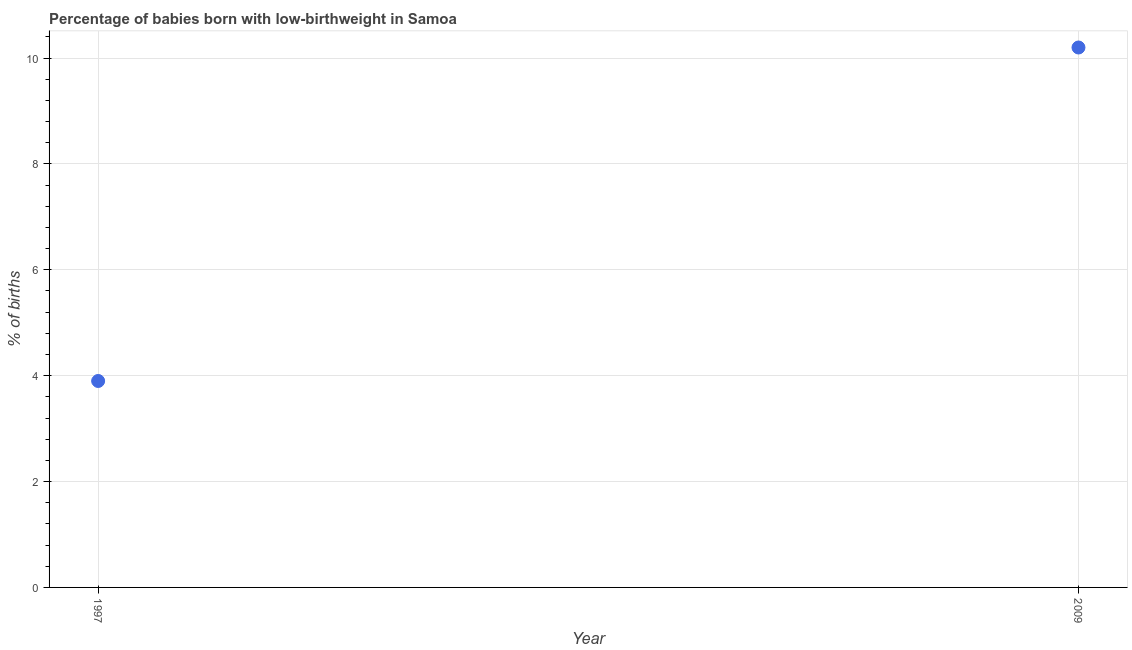What is the percentage of babies who were born with low-birthweight in 1997?
Your answer should be very brief. 3.9. In which year was the percentage of babies who were born with low-birthweight maximum?
Ensure brevity in your answer.  2009. What is the difference between the percentage of babies who were born with low-birthweight in 1997 and 2009?
Keep it short and to the point. -6.3. What is the average percentage of babies who were born with low-birthweight per year?
Ensure brevity in your answer.  7.05. What is the median percentage of babies who were born with low-birthweight?
Give a very brief answer. 7.05. Do a majority of the years between 2009 and 1997 (inclusive) have percentage of babies who were born with low-birthweight greater than 8.8 %?
Offer a very short reply. No. What is the ratio of the percentage of babies who were born with low-birthweight in 1997 to that in 2009?
Give a very brief answer. 0.38. Is the percentage of babies who were born with low-birthweight in 1997 less than that in 2009?
Your response must be concise. Yes. In how many years, is the percentage of babies who were born with low-birthweight greater than the average percentage of babies who were born with low-birthweight taken over all years?
Your answer should be very brief. 1. Does the percentage of babies who were born with low-birthweight monotonically increase over the years?
Keep it short and to the point. Yes. How many dotlines are there?
Offer a very short reply. 1. How many years are there in the graph?
Ensure brevity in your answer.  2. Are the values on the major ticks of Y-axis written in scientific E-notation?
Give a very brief answer. No. Does the graph contain grids?
Give a very brief answer. Yes. What is the title of the graph?
Ensure brevity in your answer.  Percentage of babies born with low-birthweight in Samoa. What is the label or title of the X-axis?
Your response must be concise. Year. What is the label or title of the Y-axis?
Keep it short and to the point. % of births. What is the % of births in 2009?
Provide a succinct answer. 10.2. What is the ratio of the % of births in 1997 to that in 2009?
Provide a short and direct response. 0.38. 